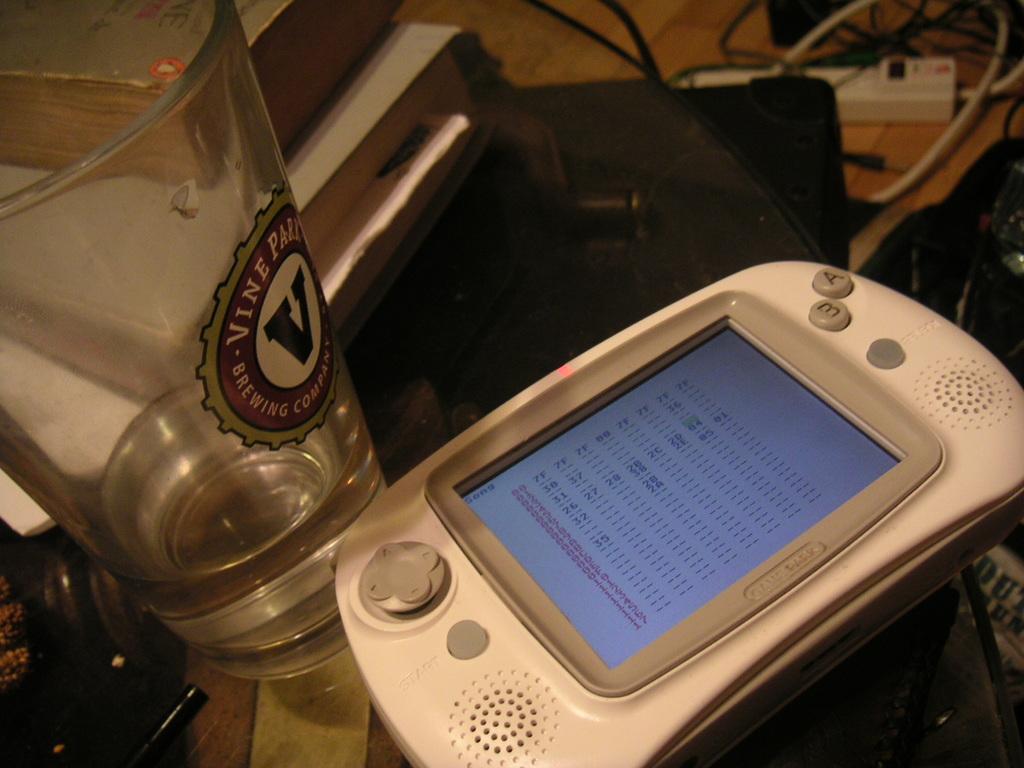What company is on the glass?
Your response must be concise. Vine park. What are the two letters on the buttons?
Provide a succinct answer. Ae. 